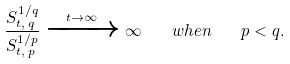Convert formula to latex. <formula><loc_0><loc_0><loc_500><loc_500>\frac { S _ { t , \, q } ^ { 1 / q } } { S _ { t , \, p } ^ { 1 / p } } \xrightarrow { t \to \infty } \infty \quad w h e n \quad p < q .</formula> 